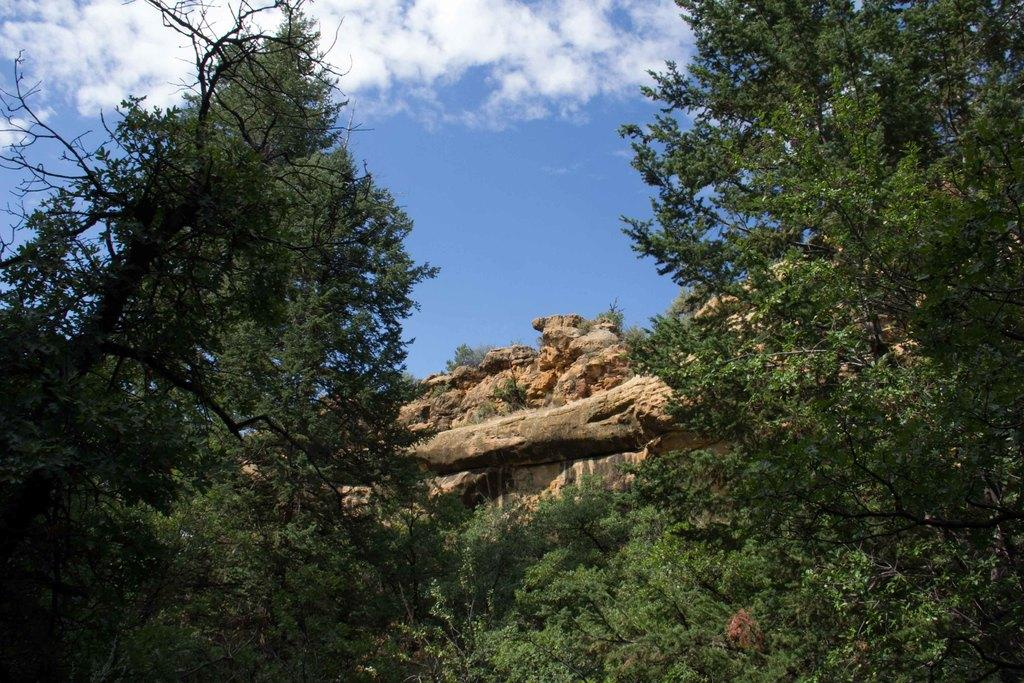What type of vegetation can be seen in the image? There are trees in the image. What other objects are present in the image? There are stones in the image. How would you describe the sky in the image? The sky is cloudy in the image. How many apples are hanging from the trees in the image? There are no apples present in the image; it only features trees and stones. Can you tell me where the faucet is located in the image? There is no faucet present in the image. 